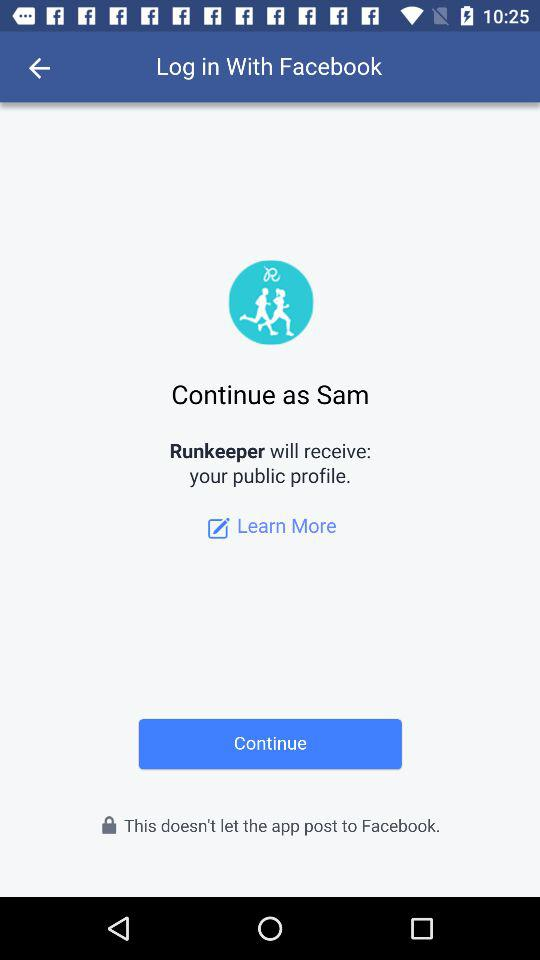What application can be used to log in? The application that can be used to log in is "Facebook". 